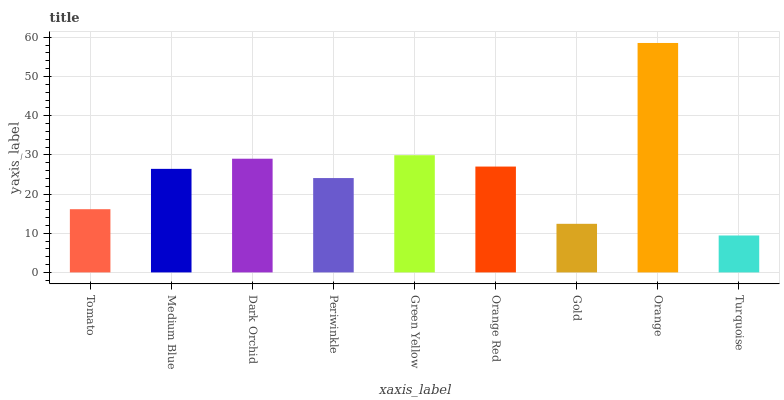Is Turquoise the minimum?
Answer yes or no. Yes. Is Orange the maximum?
Answer yes or no. Yes. Is Medium Blue the minimum?
Answer yes or no. No. Is Medium Blue the maximum?
Answer yes or no. No. Is Medium Blue greater than Tomato?
Answer yes or no. Yes. Is Tomato less than Medium Blue?
Answer yes or no. Yes. Is Tomato greater than Medium Blue?
Answer yes or no. No. Is Medium Blue less than Tomato?
Answer yes or no. No. Is Medium Blue the high median?
Answer yes or no. Yes. Is Medium Blue the low median?
Answer yes or no. Yes. Is Dark Orchid the high median?
Answer yes or no. No. Is Orange the low median?
Answer yes or no. No. 